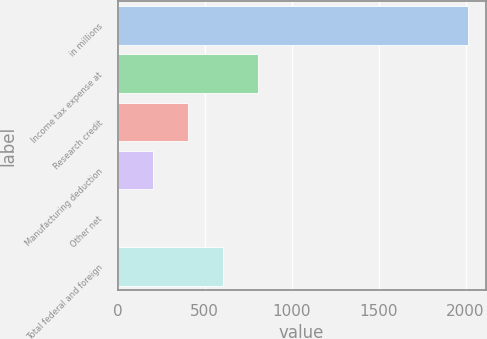Convert chart to OTSL. <chart><loc_0><loc_0><loc_500><loc_500><bar_chart><fcel>in millions<fcel>Income tax expense at<fcel>Research credit<fcel>Manufacturing deduction<fcel>Other net<fcel>Total federal and foreign<nl><fcel>2015<fcel>806.54<fcel>403.72<fcel>202.31<fcel>0.9<fcel>605.13<nl></chart> 